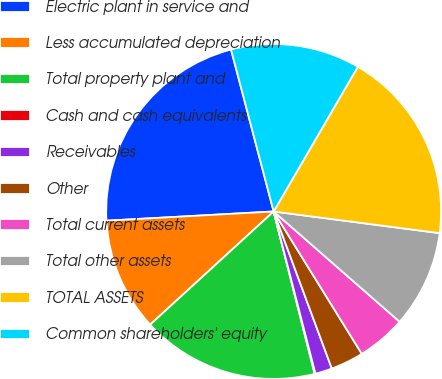<chart> <loc_0><loc_0><loc_500><loc_500><pie_chart><fcel>Electric plant in service and<fcel>Less accumulated depreciation<fcel>Total property plant and<fcel>Cash and cash equivalents<fcel>Receivables<fcel>Other<fcel>Total current assets<fcel>Total other assets<fcel>TOTAL ASSETS<fcel>Common shareholders' equity<nl><fcel>21.78%<fcel>10.93%<fcel>17.13%<fcel>0.08%<fcel>1.63%<fcel>3.18%<fcel>4.73%<fcel>9.38%<fcel>18.68%<fcel>12.48%<nl></chart> 